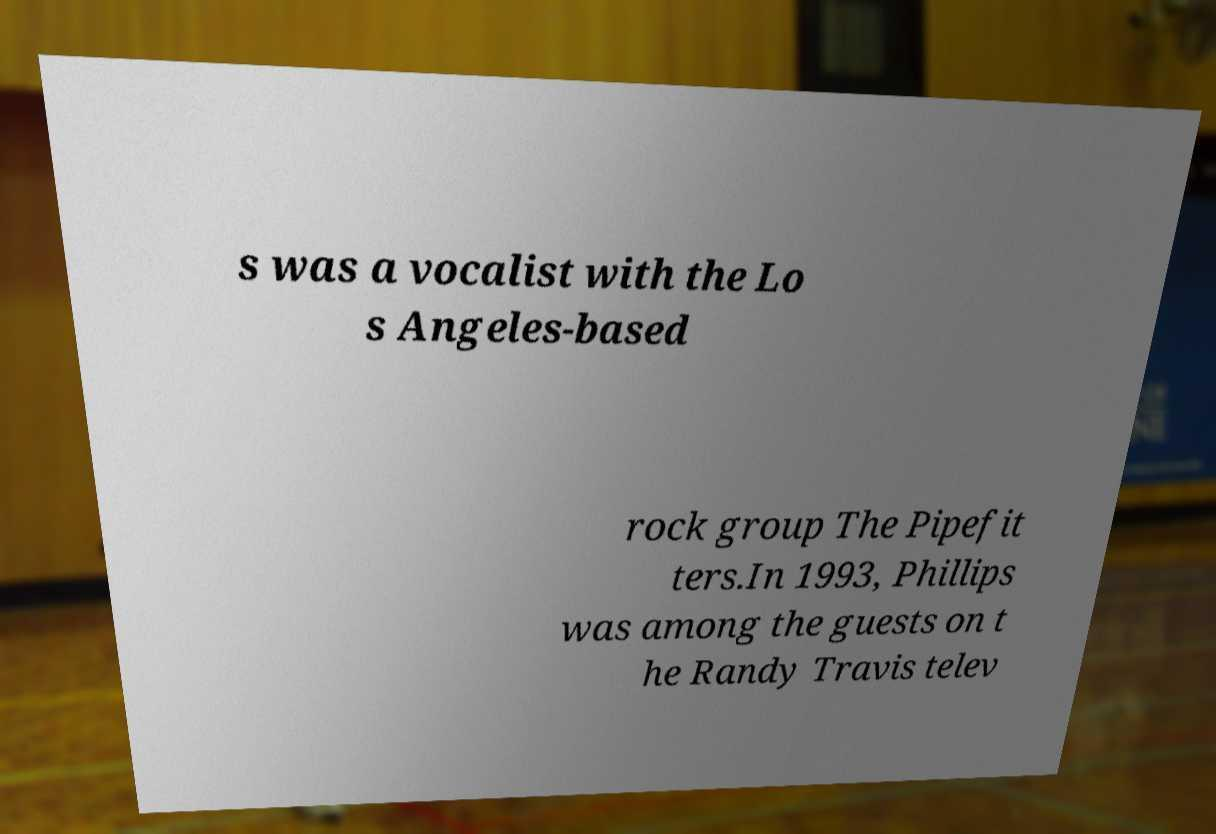Could you assist in decoding the text presented in this image and type it out clearly? s was a vocalist with the Lo s Angeles-based rock group The Pipefit ters.In 1993, Phillips was among the guests on t he Randy Travis telev 